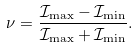Convert formula to latex. <formula><loc_0><loc_0><loc_500><loc_500>\nu = \frac { { \mathcal { I } } _ { \max } - { \mathcal { I } } _ { \min } } { { \mathcal { I } } _ { \max } + { \mathcal { I } } _ { \min } } .</formula> 